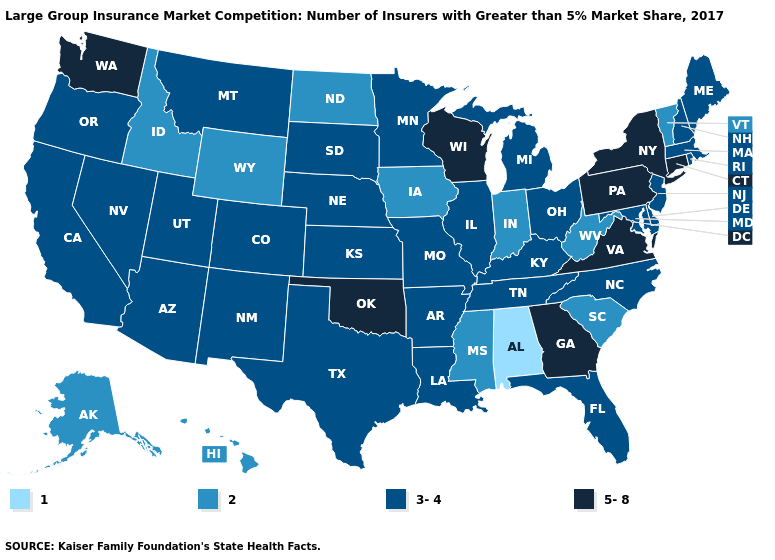Name the states that have a value in the range 2?
Keep it brief. Alaska, Hawaii, Idaho, Indiana, Iowa, Mississippi, North Dakota, South Carolina, Vermont, West Virginia, Wyoming. Which states have the highest value in the USA?
Short answer required. Connecticut, Georgia, New York, Oklahoma, Pennsylvania, Virginia, Washington, Wisconsin. Does Virginia have the highest value in the USA?
Keep it brief. Yes. Does Wisconsin have the highest value in the MidWest?
Answer briefly. Yes. What is the lowest value in the Northeast?
Short answer required. 2. Name the states that have a value in the range 2?
Give a very brief answer. Alaska, Hawaii, Idaho, Indiana, Iowa, Mississippi, North Dakota, South Carolina, Vermont, West Virginia, Wyoming. What is the lowest value in the Northeast?
Write a very short answer. 2. What is the lowest value in the West?
Write a very short answer. 2. What is the value of Mississippi?
Keep it brief. 2. What is the value of Louisiana?
Give a very brief answer. 3-4. Name the states that have a value in the range 1?
Quick response, please. Alabama. What is the value of Kentucky?
Give a very brief answer. 3-4. What is the value of Georgia?
Keep it brief. 5-8. Does North Dakota have the highest value in the MidWest?
Be succinct. No. Name the states that have a value in the range 2?
Give a very brief answer. Alaska, Hawaii, Idaho, Indiana, Iowa, Mississippi, North Dakota, South Carolina, Vermont, West Virginia, Wyoming. 